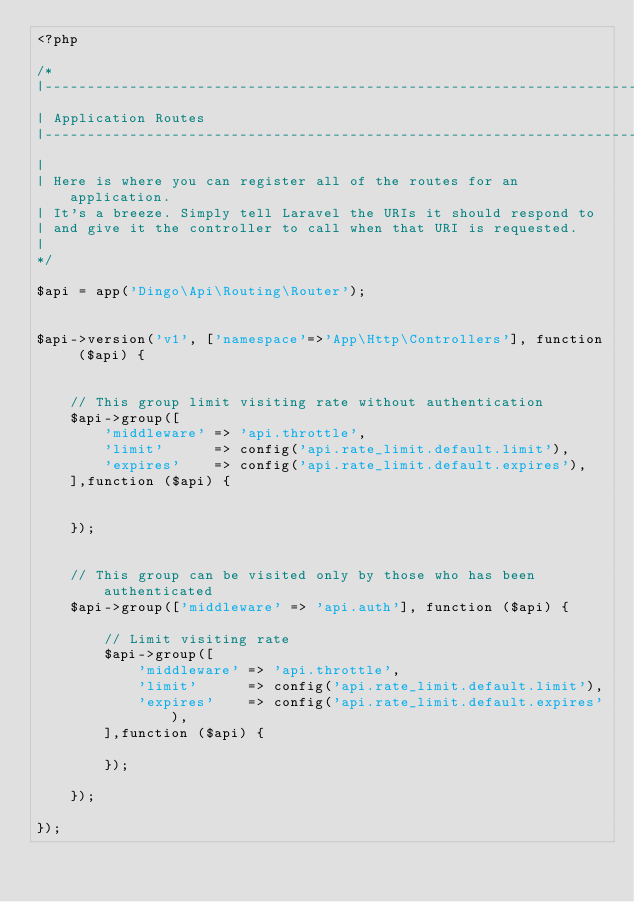Convert code to text. <code><loc_0><loc_0><loc_500><loc_500><_PHP_><?php

/*
|--------------------------------------------------------------------------
| Application Routes
|--------------------------------------------------------------------------
|
| Here is where you can register all of the routes for an application.
| It's a breeze. Simply tell Laravel the URIs it should respond to
| and give it the controller to call when that URI is requested.
|
*/

$api = app('Dingo\Api\Routing\Router');


$api->version('v1', ['namespace'=>'App\Http\Controllers'], function ($api) {


    // This group limit visiting rate without authentication
    $api->group([
        'middleware' => 'api.throttle',
        'limit'      => config('api.rate_limit.default.limit'),
        'expires'    => config('api.rate_limit.default.expires'),
    ],function ($api) {


    });


    // This group can be visited only by those who has been authenticated
    $api->group(['middleware' => 'api.auth'], function ($api) {

        // Limit visiting rate
        $api->group([
            'middleware' => 'api.throttle',
            'limit'      => config('api.rate_limit.default.limit'),
            'expires'    => config('api.rate_limit.default.expires'),
        ],function ($api) {

        });

    });

});

</code> 